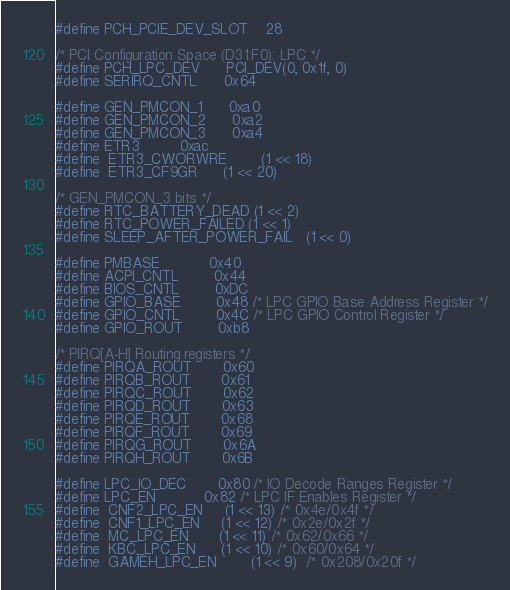<code> <loc_0><loc_0><loc_500><loc_500><_C_>#define PCH_PCIE_DEV_SLOT	28

/* PCI Configuration Space (D31:F0): LPC */
#define PCH_LPC_DEV		PCI_DEV(0, 0x1f, 0)
#define SERIRQ_CNTL		0x64

#define GEN_PMCON_1		0xa0
#define GEN_PMCON_2		0xa2
#define GEN_PMCON_3		0xa4
#define ETR3			0xac
#define  ETR3_CWORWRE		(1 << 18)
#define  ETR3_CF9GR		(1 << 20)

/* GEN_PMCON_3 bits */
#define RTC_BATTERY_DEAD	(1 << 2)
#define RTC_POWER_FAILED	(1 << 1)
#define SLEEP_AFTER_POWER_FAIL	(1 << 0)

#define PMBASE			0x40
#define ACPI_CNTL		0x44
#define BIOS_CNTL		0xDC
#define GPIO_BASE		0x48 /* LPC GPIO Base Address Register */
#define GPIO_CNTL		0x4C /* LPC GPIO Control Register */
#define GPIO_ROUT		0xb8

/* PIRQ[A-H] Routing registers */
#define PIRQA_ROUT		0x60
#define PIRQB_ROUT		0x61
#define PIRQC_ROUT		0x62
#define PIRQD_ROUT		0x63
#define PIRQE_ROUT		0x68
#define PIRQF_ROUT		0x69
#define PIRQG_ROUT		0x6A
#define PIRQH_ROUT		0x6B

#define LPC_IO_DEC		0x80 /* IO Decode Ranges Register */
#define LPC_EN			0x82 /* LPC IF Enables Register */
#define  CNF2_LPC_EN		(1 << 13) /* 0x4e/0x4f */
#define  CNF1_LPC_EN		(1 << 12) /* 0x2e/0x2f */
#define  MC_LPC_EN		(1 << 11) /* 0x62/0x66 */
#define  KBC_LPC_EN		(1 << 10) /* 0x60/0x64 */
#define  GAMEH_LPC_EN		(1 << 9)  /* 0x208/0x20f */</code> 